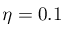<formula> <loc_0><loc_0><loc_500><loc_500>\eta = 0 . 1</formula> 